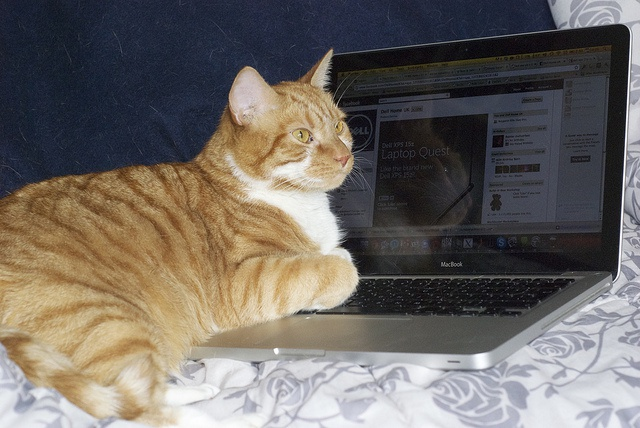Describe the objects in this image and their specific colors. I can see laptop in black, gray, and darkgray tones, bed in black, lightgray, and darkgray tones, and cat in black, tan, and olive tones in this image. 